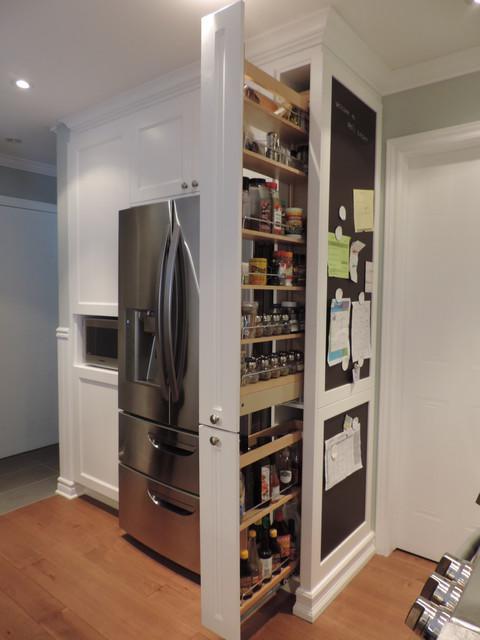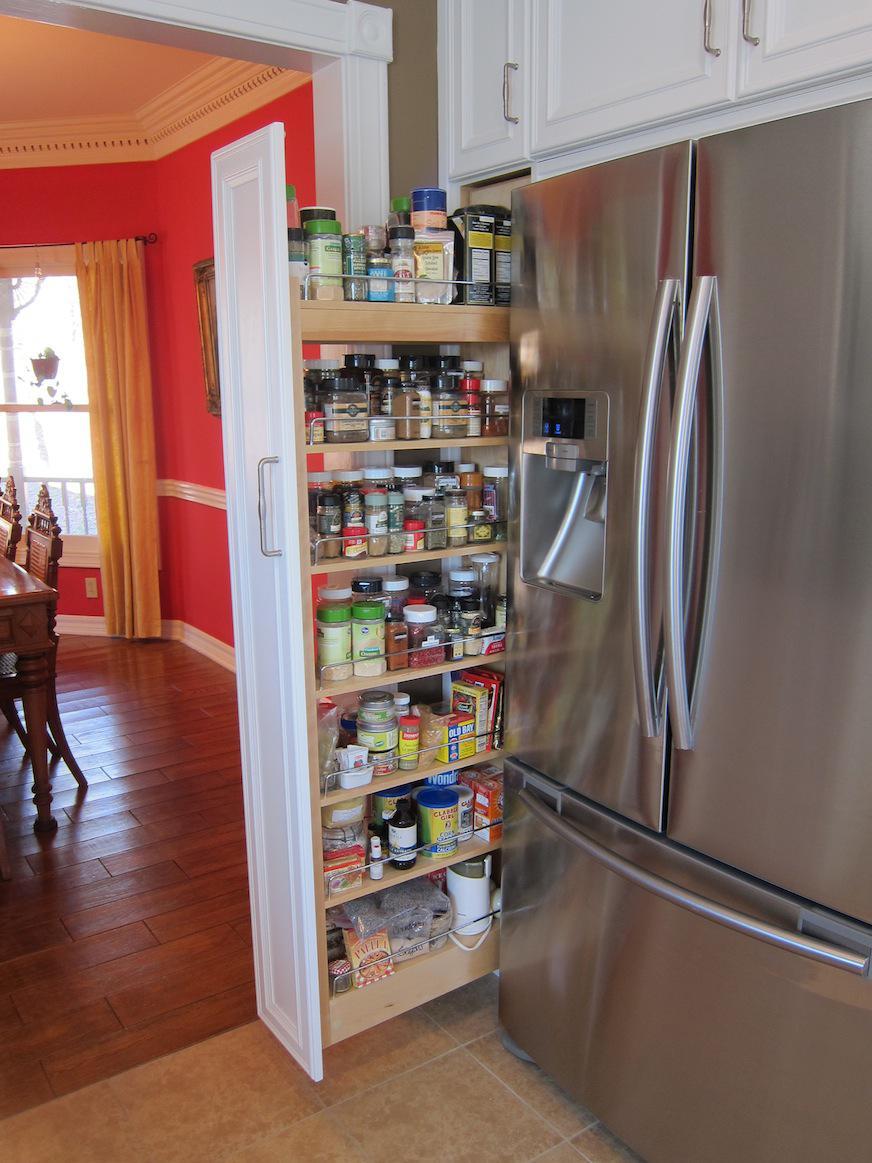The first image is the image on the left, the second image is the image on the right. For the images displayed, is the sentence "The right image shows a narrow filled pantry with a handle pulled out from behind a stainless steel refrigerator and in front of a doorway." factually correct? Answer yes or no. Yes. 